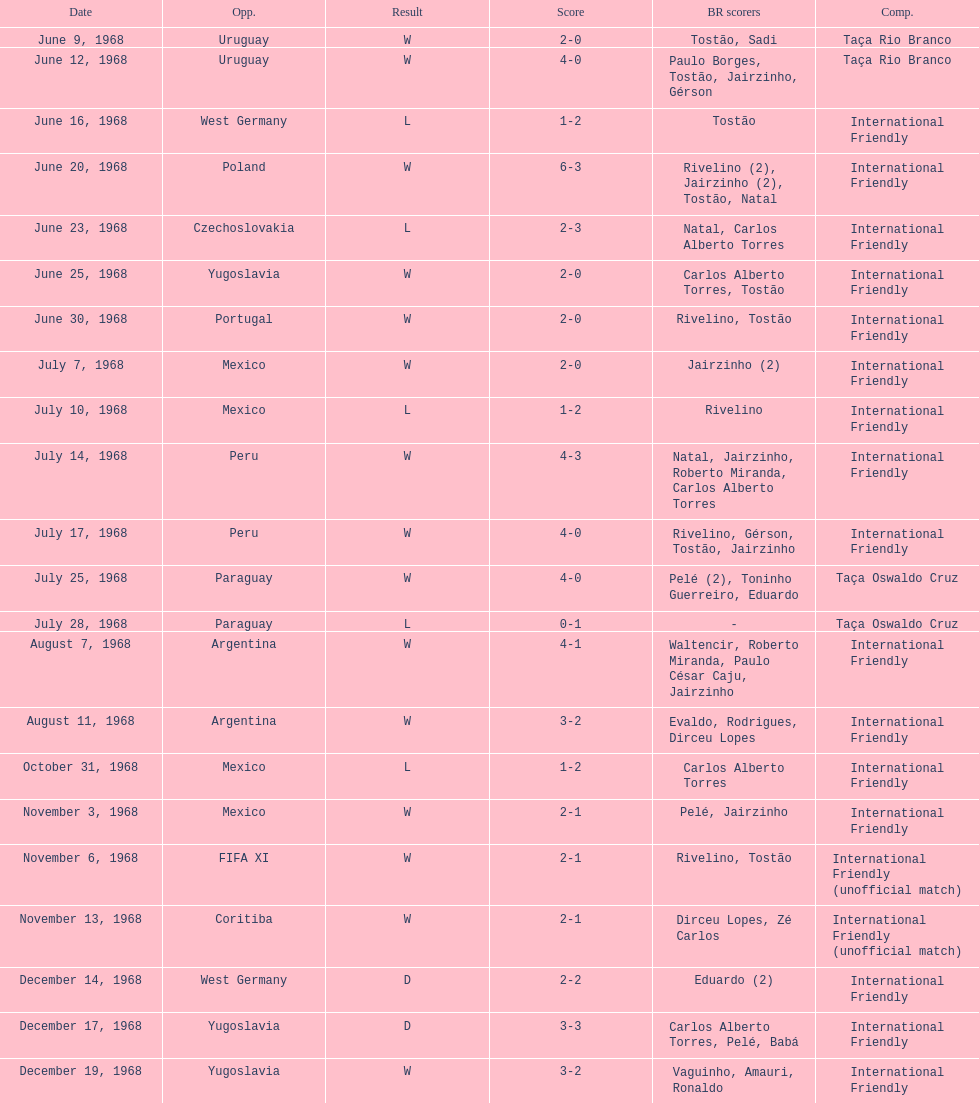What year has the highest scoring game? 1968. 